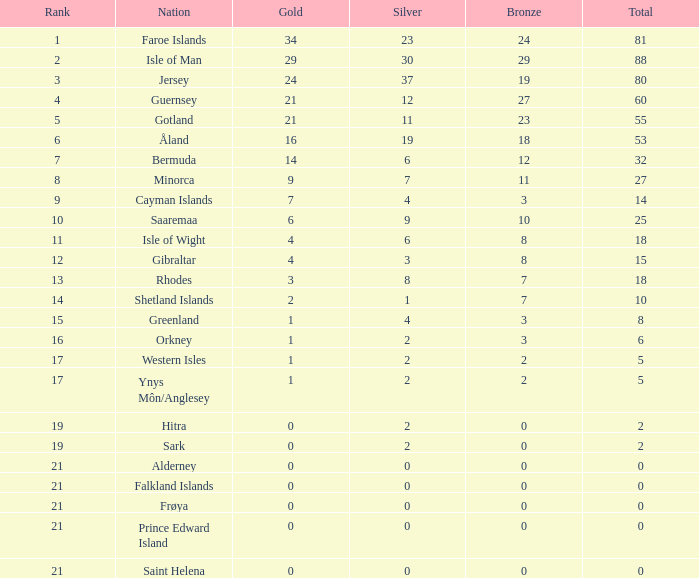How many Silver medals were won in total by all those with more than 3 bronze and exactly 16 gold? 19.0. 